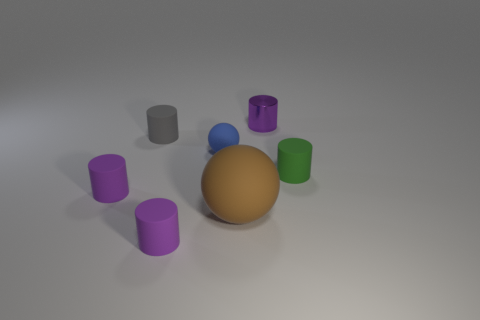What size is the other matte object that is the same shape as the brown matte object?
Keep it short and to the point. Small. Are there any other things that have the same size as the brown matte sphere?
Provide a succinct answer. No. What number of other things are the same color as the shiny cylinder?
Keep it short and to the point. 2. How many blocks are brown things or purple objects?
Provide a short and direct response. 0. There is a tiny matte cylinder that is behind the tiny matte cylinder on the right side of the small blue ball; what is its color?
Your answer should be compact. Gray. There is a big object; what shape is it?
Your answer should be very brief. Sphere. Do the cylinder to the left of the gray thing and the gray rubber cylinder have the same size?
Provide a short and direct response. Yes. Is there a large brown thing that has the same material as the small sphere?
Offer a very short reply. Yes. What number of objects are either tiny purple rubber things that are in front of the big brown ball or tiny metal things?
Offer a terse response. 2. Are there any large green rubber things?
Offer a terse response. No. 